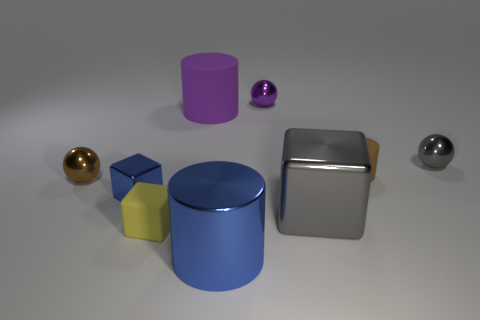Subtract all green cubes. Subtract all cyan balls. How many cubes are left? 3 Add 1 cylinders. How many objects exist? 10 Subtract all spheres. How many objects are left? 6 Add 4 brown metal balls. How many brown metal balls exist? 5 Subtract 1 purple cylinders. How many objects are left? 8 Subtract all tiny brown matte things. Subtract all tiny blue shiny cubes. How many objects are left? 7 Add 2 small purple objects. How many small purple objects are left? 3 